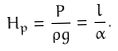<formula> <loc_0><loc_0><loc_500><loc_500>H _ { p } = \frac { P } { \rho g } = \frac { l } { \alpha } .</formula> 